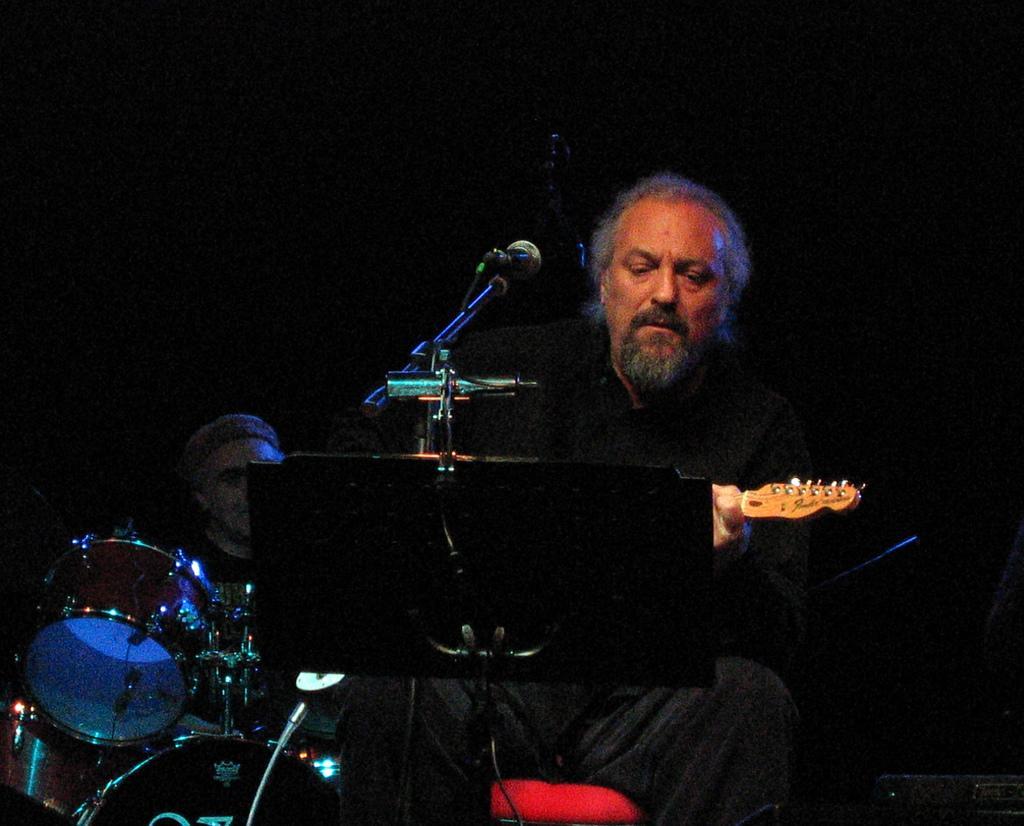How would you summarize this image in a sentence or two? In this picture we can see a man sitting and playing some musical instrument. He is wearing the black dress. In front of him there is book holder and there is a mic. To the right side of him there is a man sitting and playing drums. 